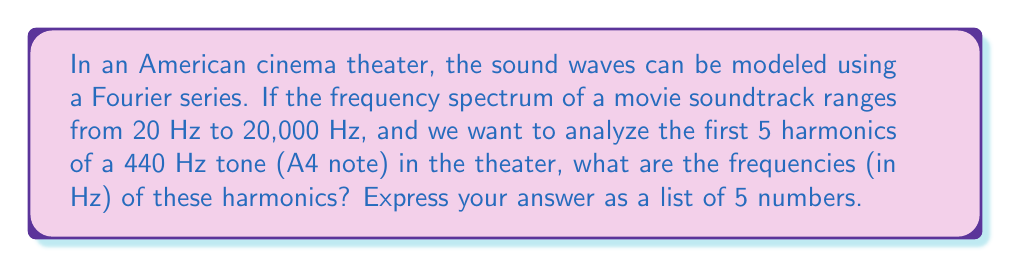Give your solution to this math problem. To understand this problem, let's break it down step-by-step:

1. The fundamental frequency (first harmonic) is given as 440 Hz. This is the A4 note in music.

2. In a Fourier series, harmonics are integer multiples of the fundamental frequency. The formula for the nth harmonic is:

   $$ f_n = n \cdot f_1 $$

   Where $f_n$ is the frequency of the nth harmonic, and $f_1$ is the fundamental frequency.

3. Let's calculate the first 5 harmonics:

   First harmonic (n = 1): $f_1 = 1 \cdot 440 = 440$ Hz
   Second harmonic (n = 2): $f_2 = 2 \cdot 440 = 880$ Hz
   Third harmonic (n = 3): $f_3 = 3 \cdot 440 = 1320$ Hz
   Fourth harmonic (n = 4): $f_4 = 4 \cdot 440 = 1760$ Hz
   Fifth harmonic (n = 5): $f_5 = 5 \cdot 440 = 2200$ Hz

4. We can verify that all these frequencies fall within the given range of 20 Hz to 20,000 Hz for the movie soundtrack.

This analysis helps in understanding how different frequencies contribute to the overall sound in the cinema theater, which is crucial for designing optimal acoustic properties.
Answer: [440, 880, 1320, 1760, 2200] 